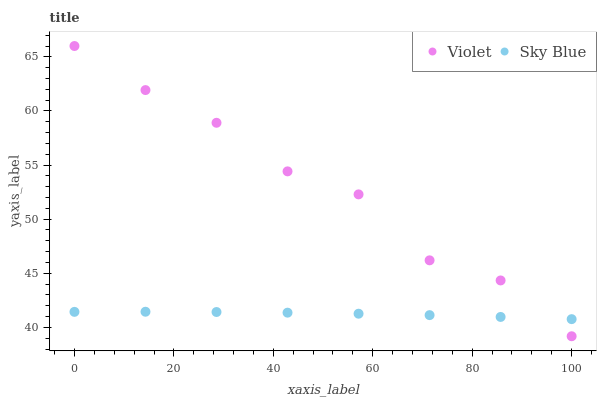Does Sky Blue have the minimum area under the curve?
Answer yes or no. Yes. Does Violet have the maximum area under the curve?
Answer yes or no. Yes. Does Violet have the minimum area under the curve?
Answer yes or no. No. Is Sky Blue the smoothest?
Answer yes or no. Yes. Is Violet the roughest?
Answer yes or no. Yes. Is Violet the smoothest?
Answer yes or no. No. Does Violet have the lowest value?
Answer yes or no. Yes. Does Violet have the highest value?
Answer yes or no. Yes. Does Violet intersect Sky Blue?
Answer yes or no. Yes. Is Violet less than Sky Blue?
Answer yes or no. No. Is Violet greater than Sky Blue?
Answer yes or no. No. 